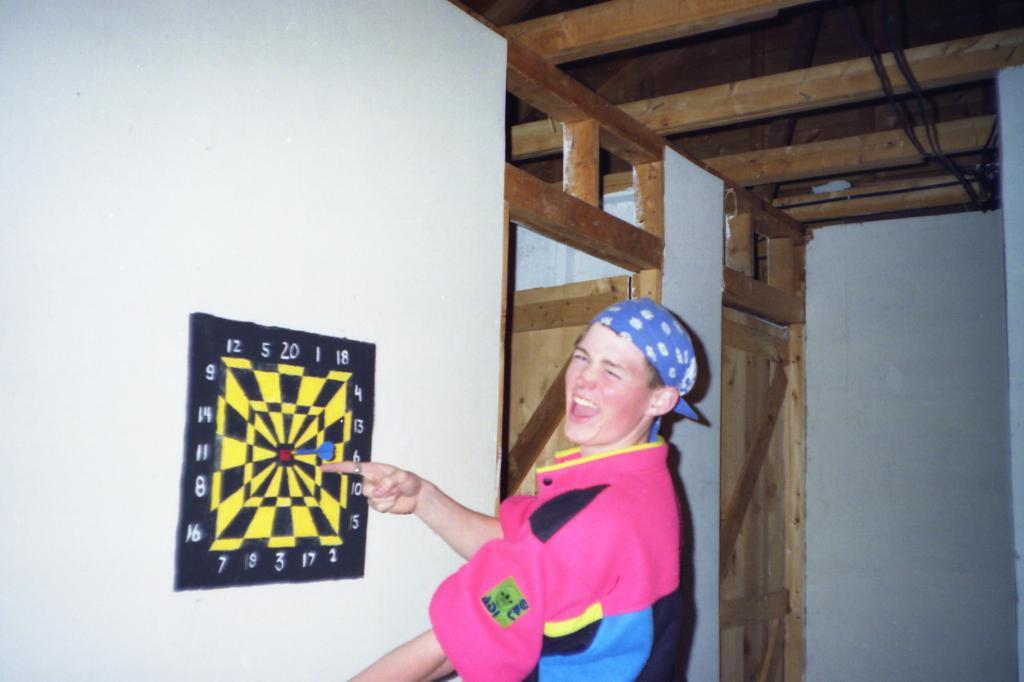What is the main subject in the center of the image? There is a man standing in the center of the image. What is the man's facial expression? The man is smiling. What can be seen hanging on the wall on the left side of the image? There is a gaming board hanging on the wall on the left side of the image. Are there any architectural features visible in the image? Yes, there are doors visible in the image. What is the color of the wall in the image? The wall is white in color. What type of bead is the man wearing around his head in the image? There is no bead or headwear visible on the man in the image. What kind of toy can be seen on the gaming board in the image? There are no toys present on the gaming board in the image; it is a hanging board on the wall. 